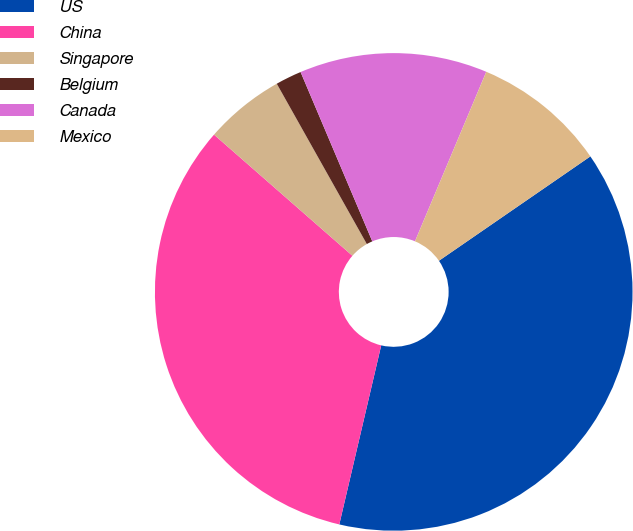Convert chart. <chart><loc_0><loc_0><loc_500><loc_500><pie_chart><fcel>US<fcel>China<fcel>Singapore<fcel>Belgium<fcel>Canada<fcel>Mexico<nl><fcel>38.26%<fcel>32.78%<fcel>5.41%<fcel>1.77%<fcel>12.71%<fcel>9.06%<nl></chart> 